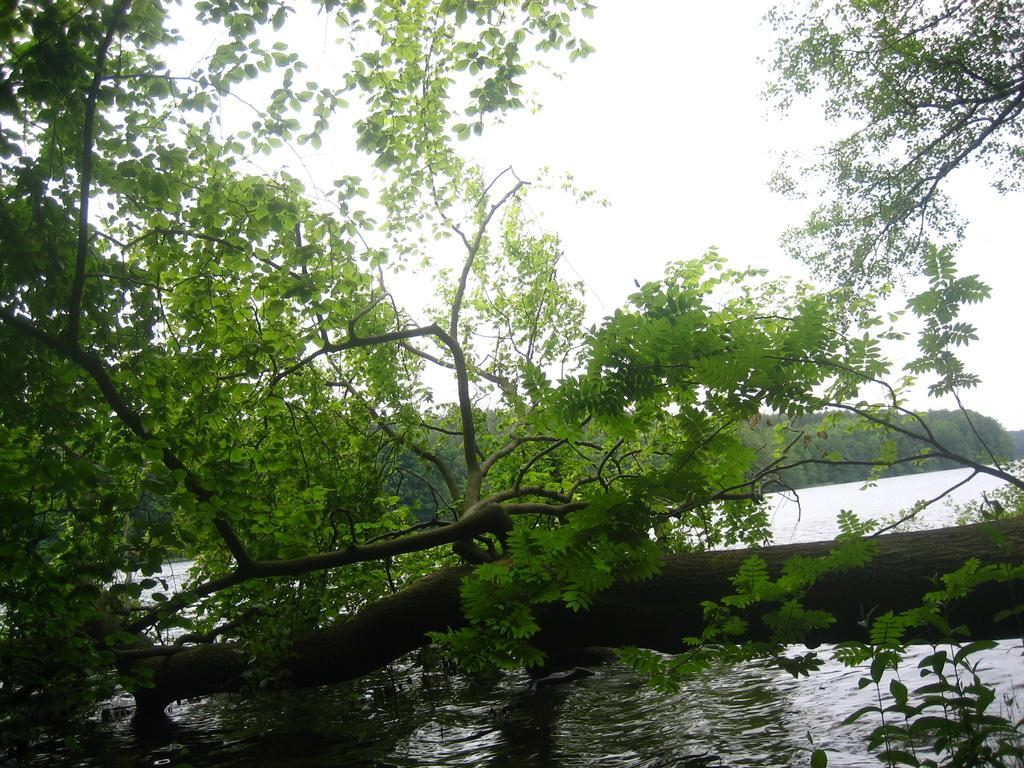What type of vegetation can be seen in the image? There are trees in the image. What part of the natural environment is visible in the image? The sky and water are visible in the image. What type of record can be seen spinning on a turntable in the image? There is no record or turntable present in the image; it features trees, sky, and water. 